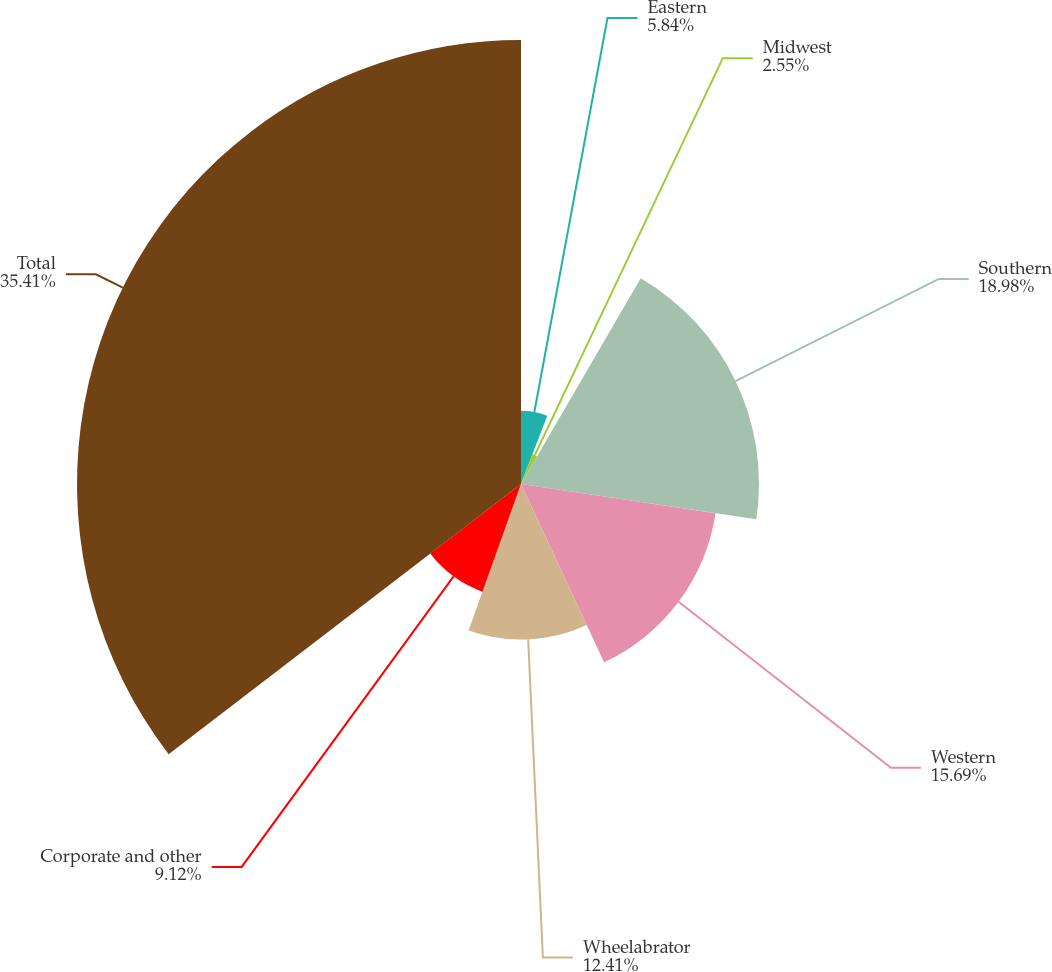Convert chart. <chart><loc_0><loc_0><loc_500><loc_500><pie_chart><fcel>Eastern<fcel>Midwest<fcel>Southern<fcel>Western<fcel>Wheelabrator<fcel>Corporate and other<fcel>Total<nl><fcel>5.84%<fcel>2.55%<fcel>18.98%<fcel>15.69%<fcel>12.41%<fcel>9.12%<fcel>35.41%<nl></chart> 